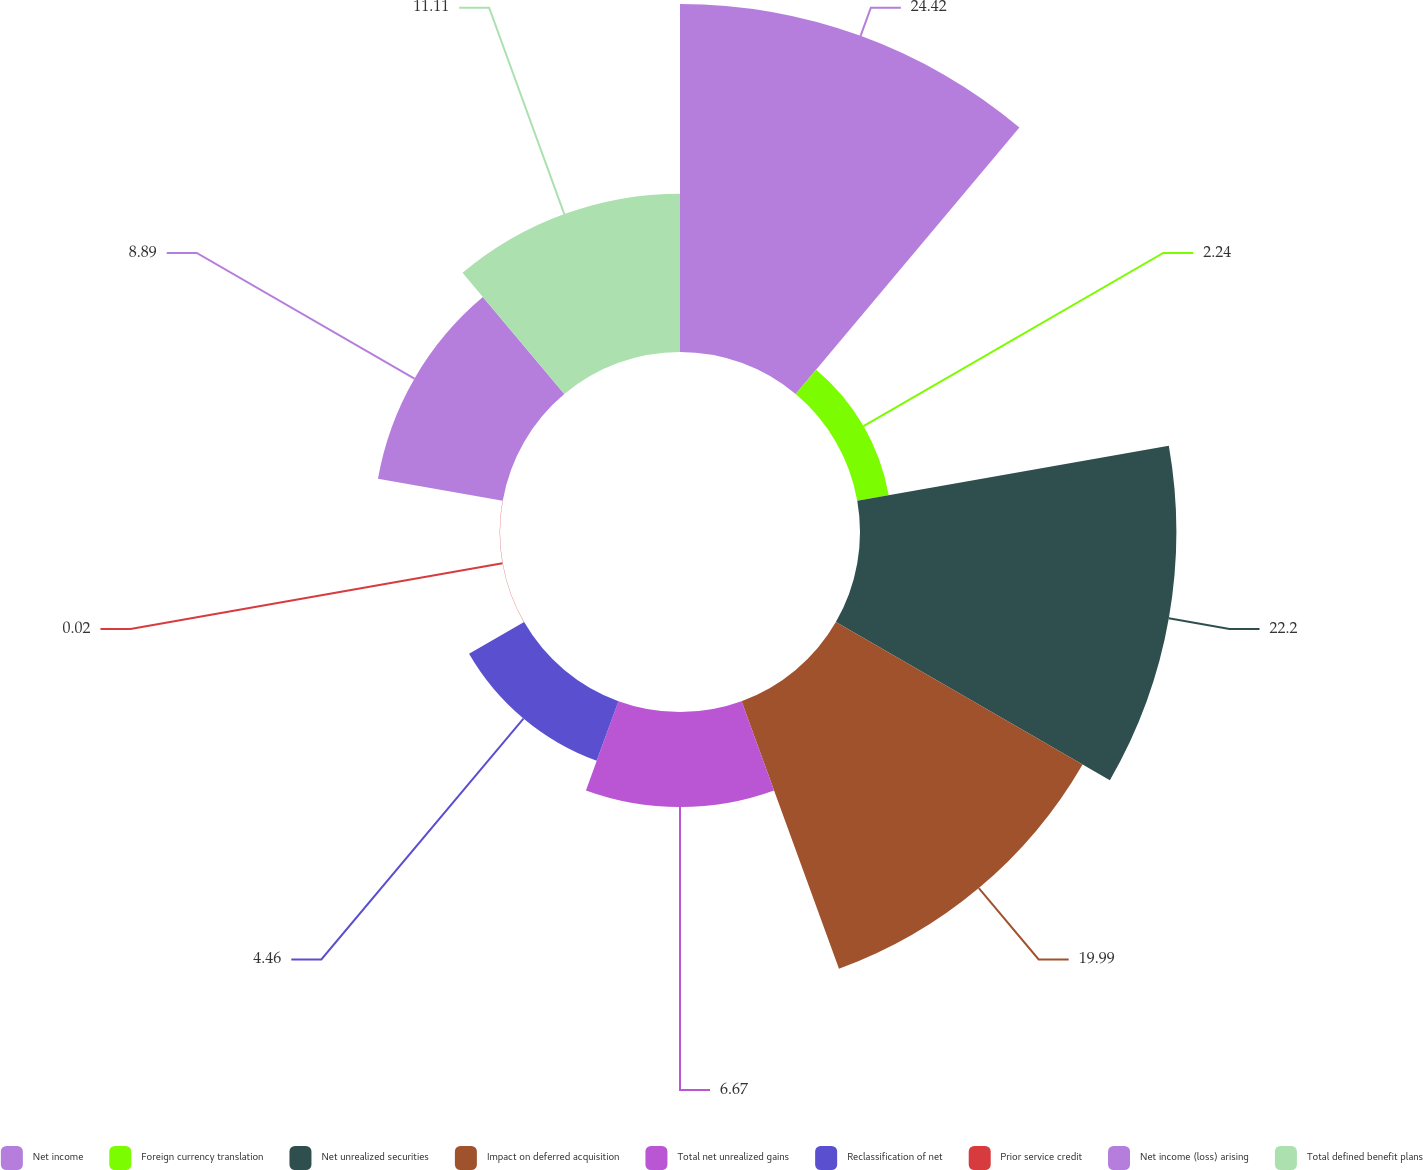Convert chart to OTSL. <chart><loc_0><loc_0><loc_500><loc_500><pie_chart><fcel>Net income<fcel>Foreign currency translation<fcel>Net unrealized securities<fcel>Impact on deferred acquisition<fcel>Total net unrealized gains<fcel>Reclassification of net<fcel>Prior service credit<fcel>Net income (loss) arising<fcel>Total defined benefit plans<nl><fcel>24.42%<fcel>2.24%<fcel>22.2%<fcel>19.99%<fcel>6.67%<fcel>4.46%<fcel>0.02%<fcel>8.89%<fcel>11.11%<nl></chart> 